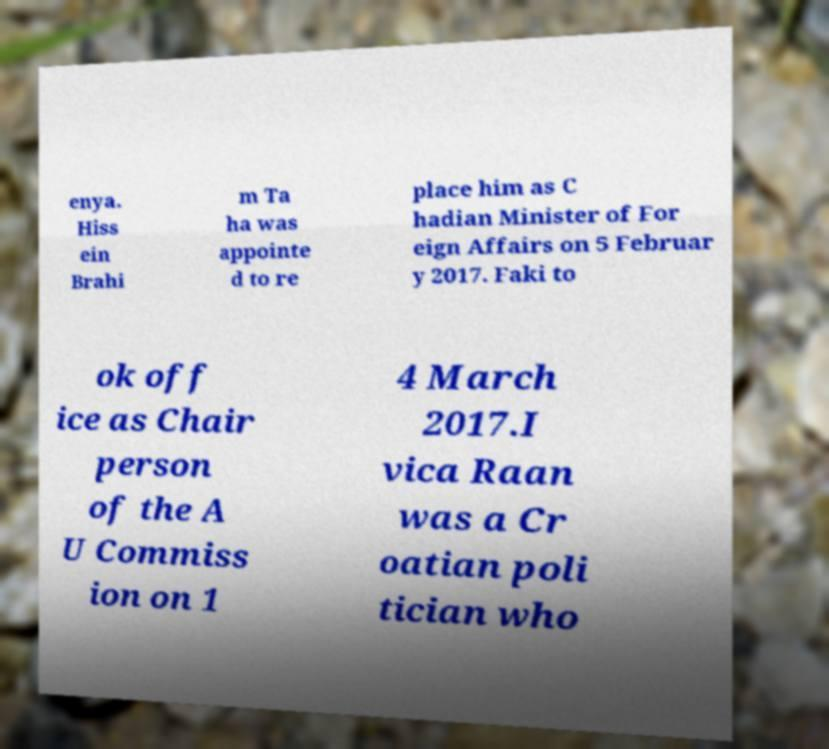Can you read and provide the text displayed in the image?This photo seems to have some interesting text. Can you extract and type it out for me? enya. Hiss ein Brahi m Ta ha was appointe d to re place him as C hadian Minister of For eign Affairs on 5 Februar y 2017. Faki to ok off ice as Chair person of the A U Commiss ion on 1 4 March 2017.I vica Raan was a Cr oatian poli tician who 